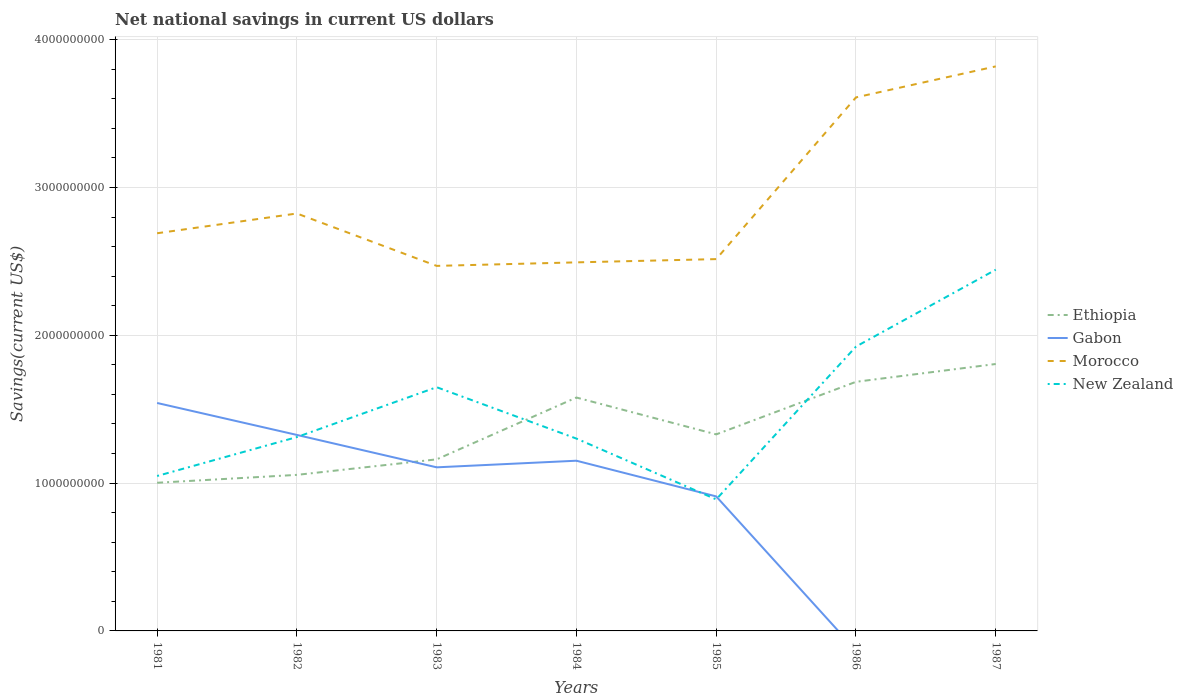How many different coloured lines are there?
Give a very brief answer. 4. Is the number of lines equal to the number of legend labels?
Make the answer very short. No. Across all years, what is the maximum net national savings in New Zealand?
Offer a very short reply. 8.90e+08. What is the total net national savings in Ethiopia in the graph?
Your answer should be very brief. -6.45e+08. What is the difference between the highest and the second highest net national savings in Morocco?
Your answer should be compact. 1.35e+09. How many years are there in the graph?
Give a very brief answer. 7. What is the difference between two consecutive major ticks on the Y-axis?
Keep it short and to the point. 1.00e+09. Are the values on the major ticks of Y-axis written in scientific E-notation?
Offer a very short reply. No. How many legend labels are there?
Keep it short and to the point. 4. What is the title of the graph?
Give a very brief answer. Net national savings in current US dollars. What is the label or title of the Y-axis?
Your response must be concise. Savings(current US$). What is the Savings(current US$) of Ethiopia in 1981?
Keep it short and to the point. 1.00e+09. What is the Savings(current US$) of Gabon in 1981?
Your answer should be compact. 1.54e+09. What is the Savings(current US$) of Morocco in 1981?
Your response must be concise. 2.69e+09. What is the Savings(current US$) in New Zealand in 1981?
Give a very brief answer. 1.05e+09. What is the Savings(current US$) of Ethiopia in 1982?
Your answer should be very brief. 1.06e+09. What is the Savings(current US$) in Gabon in 1982?
Give a very brief answer. 1.33e+09. What is the Savings(current US$) in Morocco in 1982?
Offer a terse response. 2.82e+09. What is the Savings(current US$) in New Zealand in 1982?
Provide a short and direct response. 1.31e+09. What is the Savings(current US$) in Ethiopia in 1983?
Make the answer very short. 1.16e+09. What is the Savings(current US$) of Gabon in 1983?
Your response must be concise. 1.11e+09. What is the Savings(current US$) in Morocco in 1983?
Your answer should be very brief. 2.47e+09. What is the Savings(current US$) of New Zealand in 1983?
Offer a terse response. 1.65e+09. What is the Savings(current US$) in Ethiopia in 1984?
Your answer should be compact. 1.58e+09. What is the Savings(current US$) in Gabon in 1984?
Make the answer very short. 1.15e+09. What is the Savings(current US$) of Morocco in 1984?
Offer a terse response. 2.49e+09. What is the Savings(current US$) of New Zealand in 1984?
Make the answer very short. 1.30e+09. What is the Savings(current US$) in Ethiopia in 1985?
Ensure brevity in your answer.  1.33e+09. What is the Savings(current US$) of Gabon in 1985?
Your answer should be compact. 9.10e+08. What is the Savings(current US$) in Morocco in 1985?
Your answer should be very brief. 2.52e+09. What is the Savings(current US$) in New Zealand in 1985?
Your answer should be very brief. 8.90e+08. What is the Savings(current US$) in Ethiopia in 1986?
Provide a succinct answer. 1.69e+09. What is the Savings(current US$) of Gabon in 1986?
Your response must be concise. 0. What is the Savings(current US$) in Morocco in 1986?
Keep it short and to the point. 3.61e+09. What is the Savings(current US$) in New Zealand in 1986?
Make the answer very short. 1.92e+09. What is the Savings(current US$) of Ethiopia in 1987?
Your answer should be very brief. 1.81e+09. What is the Savings(current US$) of Gabon in 1987?
Provide a succinct answer. 0. What is the Savings(current US$) in Morocco in 1987?
Provide a succinct answer. 3.82e+09. What is the Savings(current US$) in New Zealand in 1987?
Provide a short and direct response. 2.44e+09. Across all years, what is the maximum Savings(current US$) of Ethiopia?
Provide a succinct answer. 1.81e+09. Across all years, what is the maximum Savings(current US$) of Gabon?
Offer a terse response. 1.54e+09. Across all years, what is the maximum Savings(current US$) of Morocco?
Offer a very short reply. 3.82e+09. Across all years, what is the maximum Savings(current US$) in New Zealand?
Provide a succinct answer. 2.44e+09. Across all years, what is the minimum Savings(current US$) of Ethiopia?
Your answer should be compact. 1.00e+09. Across all years, what is the minimum Savings(current US$) of Morocco?
Provide a short and direct response. 2.47e+09. Across all years, what is the minimum Savings(current US$) of New Zealand?
Give a very brief answer. 8.90e+08. What is the total Savings(current US$) in Ethiopia in the graph?
Provide a short and direct response. 9.62e+09. What is the total Savings(current US$) of Gabon in the graph?
Your answer should be very brief. 6.04e+09. What is the total Savings(current US$) of Morocco in the graph?
Make the answer very short. 2.04e+1. What is the total Savings(current US$) of New Zealand in the graph?
Give a very brief answer. 1.06e+1. What is the difference between the Savings(current US$) of Ethiopia in 1981 and that in 1982?
Ensure brevity in your answer.  -5.34e+07. What is the difference between the Savings(current US$) in Gabon in 1981 and that in 1982?
Ensure brevity in your answer.  2.16e+08. What is the difference between the Savings(current US$) of Morocco in 1981 and that in 1982?
Your answer should be compact. -1.34e+08. What is the difference between the Savings(current US$) in New Zealand in 1981 and that in 1982?
Offer a very short reply. -2.63e+08. What is the difference between the Savings(current US$) in Ethiopia in 1981 and that in 1983?
Make the answer very short. -1.58e+08. What is the difference between the Savings(current US$) in Gabon in 1981 and that in 1983?
Make the answer very short. 4.35e+08. What is the difference between the Savings(current US$) in Morocco in 1981 and that in 1983?
Offer a very short reply. 2.21e+08. What is the difference between the Savings(current US$) of New Zealand in 1981 and that in 1983?
Provide a short and direct response. -6.01e+08. What is the difference between the Savings(current US$) of Ethiopia in 1981 and that in 1984?
Give a very brief answer. -5.77e+08. What is the difference between the Savings(current US$) of Gabon in 1981 and that in 1984?
Offer a terse response. 3.91e+08. What is the difference between the Savings(current US$) in Morocco in 1981 and that in 1984?
Ensure brevity in your answer.  1.97e+08. What is the difference between the Savings(current US$) of New Zealand in 1981 and that in 1984?
Keep it short and to the point. -2.53e+08. What is the difference between the Savings(current US$) of Ethiopia in 1981 and that in 1985?
Provide a short and direct response. -3.27e+08. What is the difference between the Savings(current US$) in Gabon in 1981 and that in 1985?
Provide a short and direct response. 6.32e+08. What is the difference between the Savings(current US$) of Morocco in 1981 and that in 1985?
Your response must be concise. 1.75e+08. What is the difference between the Savings(current US$) of New Zealand in 1981 and that in 1985?
Your answer should be compact. 1.58e+08. What is the difference between the Savings(current US$) in Ethiopia in 1981 and that in 1986?
Provide a succinct answer. -6.83e+08. What is the difference between the Savings(current US$) in Morocco in 1981 and that in 1986?
Provide a short and direct response. -9.19e+08. What is the difference between the Savings(current US$) in New Zealand in 1981 and that in 1986?
Offer a terse response. -8.76e+08. What is the difference between the Savings(current US$) in Ethiopia in 1981 and that in 1987?
Offer a very short reply. -8.04e+08. What is the difference between the Savings(current US$) in Morocco in 1981 and that in 1987?
Provide a short and direct response. -1.13e+09. What is the difference between the Savings(current US$) of New Zealand in 1981 and that in 1987?
Give a very brief answer. -1.40e+09. What is the difference between the Savings(current US$) of Ethiopia in 1982 and that in 1983?
Provide a short and direct response. -1.05e+08. What is the difference between the Savings(current US$) of Gabon in 1982 and that in 1983?
Offer a terse response. 2.19e+08. What is the difference between the Savings(current US$) in Morocco in 1982 and that in 1983?
Your answer should be compact. 3.55e+08. What is the difference between the Savings(current US$) in New Zealand in 1982 and that in 1983?
Provide a short and direct response. -3.37e+08. What is the difference between the Savings(current US$) of Ethiopia in 1982 and that in 1984?
Keep it short and to the point. -5.23e+08. What is the difference between the Savings(current US$) in Gabon in 1982 and that in 1984?
Give a very brief answer. 1.74e+08. What is the difference between the Savings(current US$) of Morocco in 1982 and that in 1984?
Your response must be concise. 3.31e+08. What is the difference between the Savings(current US$) in New Zealand in 1982 and that in 1984?
Provide a short and direct response. 1.02e+07. What is the difference between the Savings(current US$) of Ethiopia in 1982 and that in 1985?
Provide a succinct answer. -2.74e+08. What is the difference between the Savings(current US$) in Gabon in 1982 and that in 1985?
Make the answer very short. 4.16e+08. What is the difference between the Savings(current US$) of Morocco in 1982 and that in 1985?
Offer a very short reply. 3.09e+08. What is the difference between the Savings(current US$) in New Zealand in 1982 and that in 1985?
Ensure brevity in your answer.  4.22e+08. What is the difference between the Savings(current US$) of Ethiopia in 1982 and that in 1986?
Provide a succinct answer. -6.30e+08. What is the difference between the Savings(current US$) of Morocco in 1982 and that in 1986?
Ensure brevity in your answer.  -7.86e+08. What is the difference between the Savings(current US$) in New Zealand in 1982 and that in 1986?
Make the answer very short. -6.12e+08. What is the difference between the Savings(current US$) of Ethiopia in 1982 and that in 1987?
Offer a terse response. -7.50e+08. What is the difference between the Savings(current US$) of Morocco in 1982 and that in 1987?
Provide a short and direct response. -9.95e+08. What is the difference between the Savings(current US$) in New Zealand in 1982 and that in 1987?
Offer a very short reply. -1.13e+09. What is the difference between the Savings(current US$) in Ethiopia in 1983 and that in 1984?
Provide a short and direct response. -4.18e+08. What is the difference between the Savings(current US$) in Gabon in 1983 and that in 1984?
Provide a succinct answer. -4.47e+07. What is the difference between the Savings(current US$) in Morocco in 1983 and that in 1984?
Your response must be concise. -2.38e+07. What is the difference between the Savings(current US$) of New Zealand in 1983 and that in 1984?
Provide a succinct answer. 3.48e+08. What is the difference between the Savings(current US$) of Ethiopia in 1983 and that in 1985?
Make the answer very short. -1.69e+08. What is the difference between the Savings(current US$) in Gabon in 1983 and that in 1985?
Provide a succinct answer. 1.97e+08. What is the difference between the Savings(current US$) of Morocco in 1983 and that in 1985?
Make the answer very short. -4.58e+07. What is the difference between the Savings(current US$) in New Zealand in 1983 and that in 1985?
Offer a terse response. 7.59e+08. What is the difference between the Savings(current US$) of Ethiopia in 1983 and that in 1986?
Provide a succinct answer. -5.25e+08. What is the difference between the Savings(current US$) of Morocco in 1983 and that in 1986?
Offer a very short reply. -1.14e+09. What is the difference between the Savings(current US$) in New Zealand in 1983 and that in 1986?
Provide a succinct answer. -2.75e+08. What is the difference between the Savings(current US$) in Ethiopia in 1983 and that in 1987?
Provide a succinct answer. -6.45e+08. What is the difference between the Savings(current US$) of Morocco in 1983 and that in 1987?
Offer a terse response. -1.35e+09. What is the difference between the Savings(current US$) of New Zealand in 1983 and that in 1987?
Provide a short and direct response. -7.95e+08. What is the difference between the Savings(current US$) of Ethiopia in 1984 and that in 1985?
Keep it short and to the point. 2.49e+08. What is the difference between the Savings(current US$) in Gabon in 1984 and that in 1985?
Your answer should be very brief. 2.42e+08. What is the difference between the Savings(current US$) in Morocco in 1984 and that in 1985?
Your answer should be very brief. -2.20e+07. What is the difference between the Savings(current US$) of New Zealand in 1984 and that in 1985?
Provide a short and direct response. 4.11e+08. What is the difference between the Savings(current US$) of Ethiopia in 1984 and that in 1986?
Keep it short and to the point. -1.06e+08. What is the difference between the Savings(current US$) in Morocco in 1984 and that in 1986?
Provide a short and direct response. -1.12e+09. What is the difference between the Savings(current US$) in New Zealand in 1984 and that in 1986?
Your response must be concise. -6.22e+08. What is the difference between the Savings(current US$) of Ethiopia in 1984 and that in 1987?
Ensure brevity in your answer.  -2.27e+08. What is the difference between the Savings(current US$) of Morocco in 1984 and that in 1987?
Your response must be concise. -1.33e+09. What is the difference between the Savings(current US$) of New Zealand in 1984 and that in 1987?
Your answer should be compact. -1.14e+09. What is the difference between the Savings(current US$) in Ethiopia in 1985 and that in 1986?
Provide a short and direct response. -3.56e+08. What is the difference between the Savings(current US$) of Morocco in 1985 and that in 1986?
Offer a terse response. -1.09e+09. What is the difference between the Savings(current US$) of New Zealand in 1985 and that in 1986?
Your answer should be compact. -1.03e+09. What is the difference between the Savings(current US$) in Ethiopia in 1985 and that in 1987?
Provide a succinct answer. -4.76e+08. What is the difference between the Savings(current US$) in Morocco in 1985 and that in 1987?
Ensure brevity in your answer.  -1.30e+09. What is the difference between the Savings(current US$) in New Zealand in 1985 and that in 1987?
Provide a succinct answer. -1.55e+09. What is the difference between the Savings(current US$) of Ethiopia in 1986 and that in 1987?
Ensure brevity in your answer.  -1.20e+08. What is the difference between the Savings(current US$) in Morocco in 1986 and that in 1987?
Your response must be concise. -2.10e+08. What is the difference between the Savings(current US$) in New Zealand in 1986 and that in 1987?
Provide a succinct answer. -5.20e+08. What is the difference between the Savings(current US$) in Ethiopia in 1981 and the Savings(current US$) in Gabon in 1982?
Your answer should be very brief. -3.24e+08. What is the difference between the Savings(current US$) in Ethiopia in 1981 and the Savings(current US$) in Morocco in 1982?
Make the answer very short. -1.82e+09. What is the difference between the Savings(current US$) in Ethiopia in 1981 and the Savings(current US$) in New Zealand in 1982?
Offer a terse response. -3.09e+08. What is the difference between the Savings(current US$) of Gabon in 1981 and the Savings(current US$) of Morocco in 1982?
Provide a succinct answer. -1.28e+09. What is the difference between the Savings(current US$) of Gabon in 1981 and the Savings(current US$) of New Zealand in 1982?
Provide a succinct answer. 2.31e+08. What is the difference between the Savings(current US$) in Morocco in 1981 and the Savings(current US$) in New Zealand in 1982?
Your response must be concise. 1.38e+09. What is the difference between the Savings(current US$) of Ethiopia in 1981 and the Savings(current US$) of Gabon in 1983?
Your response must be concise. -1.05e+08. What is the difference between the Savings(current US$) in Ethiopia in 1981 and the Savings(current US$) in Morocco in 1983?
Make the answer very short. -1.47e+09. What is the difference between the Savings(current US$) in Ethiopia in 1981 and the Savings(current US$) in New Zealand in 1983?
Your answer should be compact. -6.47e+08. What is the difference between the Savings(current US$) of Gabon in 1981 and the Savings(current US$) of Morocco in 1983?
Provide a succinct answer. -9.28e+08. What is the difference between the Savings(current US$) of Gabon in 1981 and the Savings(current US$) of New Zealand in 1983?
Provide a short and direct response. -1.07e+08. What is the difference between the Savings(current US$) in Morocco in 1981 and the Savings(current US$) in New Zealand in 1983?
Make the answer very short. 1.04e+09. What is the difference between the Savings(current US$) of Ethiopia in 1981 and the Savings(current US$) of Gabon in 1984?
Provide a succinct answer. -1.49e+08. What is the difference between the Savings(current US$) in Ethiopia in 1981 and the Savings(current US$) in Morocco in 1984?
Ensure brevity in your answer.  -1.49e+09. What is the difference between the Savings(current US$) in Ethiopia in 1981 and the Savings(current US$) in New Zealand in 1984?
Offer a terse response. -2.99e+08. What is the difference between the Savings(current US$) of Gabon in 1981 and the Savings(current US$) of Morocco in 1984?
Give a very brief answer. -9.51e+08. What is the difference between the Savings(current US$) in Gabon in 1981 and the Savings(current US$) in New Zealand in 1984?
Your response must be concise. 2.41e+08. What is the difference between the Savings(current US$) of Morocco in 1981 and the Savings(current US$) of New Zealand in 1984?
Keep it short and to the point. 1.39e+09. What is the difference between the Savings(current US$) of Ethiopia in 1981 and the Savings(current US$) of Gabon in 1985?
Ensure brevity in your answer.  9.23e+07. What is the difference between the Savings(current US$) in Ethiopia in 1981 and the Savings(current US$) in Morocco in 1985?
Provide a succinct answer. -1.51e+09. What is the difference between the Savings(current US$) of Ethiopia in 1981 and the Savings(current US$) of New Zealand in 1985?
Your answer should be very brief. 1.12e+08. What is the difference between the Savings(current US$) in Gabon in 1981 and the Savings(current US$) in Morocco in 1985?
Offer a very short reply. -9.73e+08. What is the difference between the Savings(current US$) of Gabon in 1981 and the Savings(current US$) of New Zealand in 1985?
Ensure brevity in your answer.  6.52e+08. What is the difference between the Savings(current US$) in Morocco in 1981 and the Savings(current US$) in New Zealand in 1985?
Your answer should be compact. 1.80e+09. What is the difference between the Savings(current US$) of Ethiopia in 1981 and the Savings(current US$) of Morocco in 1986?
Your response must be concise. -2.61e+09. What is the difference between the Savings(current US$) in Ethiopia in 1981 and the Savings(current US$) in New Zealand in 1986?
Your answer should be compact. -9.21e+08. What is the difference between the Savings(current US$) of Gabon in 1981 and the Savings(current US$) of Morocco in 1986?
Keep it short and to the point. -2.07e+09. What is the difference between the Savings(current US$) in Gabon in 1981 and the Savings(current US$) in New Zealand in 1986?
Your response must be concise. -3.81e+08. What is the difference between the Savings(current US$) in Morocco in 1981 and the Savings(current US$) in New Zealand in 1986?
Provide a short and direct response. 7.67e+08. What is the difference between the Savings(current US$) of Ethiopia in 1981 and the Savings(current US$) of Morocco in 1987?
Offer a terse response. -2.82e+09. What is the difference between the Savings(current US$) of Ethiopia in 1981 and the Savings(current US$) of New Zealand in 1987?
Give a very brief answer. -1.44e+09. What is the difference between the Savings(current US$) of Gabon in 1981 and the Savings(current US$) of Morocco in 1987?
Offer a very short reply. -2.28e+09. What is the difference between the Savings(current US$) in Gabon in 1981 and the Savings(current US$) in New Zealand in 1987?
Provide a succinct answer. -9.02e+08. What is the difference between the Savings(current US$) of Morocco in 1981 and the Savings(current US$) of New Zealand in 1987?
Keep it short and to the point. 2.47e+08. What is the difference between the Savings(current US$) of Ethiopia in 1982 and the Savings(current US$) of Gabon in 1983?
Provide a succinct answer. -5.11e+07. What is the difference between the Savings(current US$) in Ethiopia in 1982 and the Savings(current US$) in Morocco in 1983?
Ensure brevity in your answer.  -1.41e+09. What is the difference between the Savings(current US$) in Ethiopia in 1982 and the Savings(current US$) in New Zealand in 1983?
Give a very brief answer. -5.93e+08. What is the difference between the Savings(current US$) in Gabon in 1982 and the Savings(current US$) in Morocco in 1983?
Give a very brief answer. -1.14e+09. What is the difference between the Savings(current US$) in Gabon in 1982 and the Savings(current US$) in New Zealand in 1983?
Your answer should be compact. -3.23e+08. What is the difference between the Savings(current US$) in Morocco in 1982 and the Savings(current US$) in New Zealand in 1983?
Provide a short and direct response. 1.18e+09. What is the difference between the Savings(current US$) in Ethiopia in 1982 and the Savings(current US$) in Gabon in 1984?
Offer a terse response. -9.58e+07. What is the difference between the Savings(current US$) of Ethiopia in 1982 and the Savings(current US$) of Morocco in 1984?
Keep it short and to the point. -1.44e+09. What is the difference between the Savings(current US$) of Ethiopia in 1982 and the Savings(current US$) of New Zealand in 1984?
Give a very brief answer. -2.46e+08. What is the difference between the Savings(current US$) of Gabon in 1982 and the Savings(current US$) of Morocco in 1984?
Keep it short and to the point. -1.17e+09. What is the difference between the Savings(current US$) in Gabon in 1982 and the Savings(current US$) in New Zealand in 1984?
Ensure brevity in your answer.  2.48e+07. What is the difference between the Savings(current US$) of Morocco in 1982 and the Savings(current US$) of New Zealand in 1984?
Ensure brevity in your answer.  1.52e+09. What is the difference between the Savings(current US$) of Ethiopia in 1982 and the Savings(current US$) of Gabon in 1985?
Offer a terse response. 1.46e+08. What is the difference between the Savings(current US$) in Ethiopia in 1982 and the Savings(current US$) in Morocco in 1985?
Your response must be concise. -1.46e+09. What is the difference between the Savings(current US$) of Ethiopia in 1982 and the Savings(current US$) of New Zealand in 1985?
Your response must be concise. 1.66e+08. What is the difference between the Savings(current US$) in Gabon in 1982 and the Savings(current US$) in Morocco in 1985?
Offer a terse response. -1.19e+09. What is the difference between the Savings(current US$) of Gabon in 1982 and the Savings(current US$) of New Zealand in 1985?
Provide a succinct answer. 4.36e+08. What is the difference between the Savings(current US$) of Morocco in 1982 and the Savings(current US$) of New Zealand in 1985?
Your response must be concise. 1.93e+09. What is the difference between the Savings(current US$) of Ethiopia in 1982 and the Savings(current US$) of Morocco in 1986?
Provide a short and direct response. -2.55e+09. What is the difference between the Savings(current US$) in Ethiopia in 1982 and the Savings(current US$) in New Zealand in 1986?
Offer a very short reply. -8.68e+08. What is the difference between the Savings(current US$) in Gabon in 1982 and the Savings(current US$) in Morocco in 1986?
Your response must be concise. -2.28e+09. What is the difference between the Savings(current US$) of Gabon in 1982 and the Savings(current US$) of New Zealand in 1986?
Your response must be concise. -5.98e+08. What is the difference between the Savings(current US$) of Morocco in 1982 and the Savings(current US$) of New Zealand in 1986?
Your response must be concise. 9.01e+08. What is the difference between the Savings(current US$) in Ethiopia in 1982 and the Savings(current US$) in Morocco in 1987?
Make the answer very short. -2.76e+09. What is the difference between the Savings(current US$) of Ethiopia in 1982 and the Savings(current US$) of New Zealand in 1987?
Provide a succinct answer. -1.39e+09. What is the difference between the Savings(current US$) of Gabon in 1982 and the Savings(current US$) of Morocco in 1987?
Provide a short and direct response. -2.49e+09. What is the difference between the Savings(current US$) in Gabon in 1982 and the Savings(current US$) in New Zealand in 1987?
Your answer should be very brief. -1.12e+09. What is the difference between the Savings(current US$) of Morocco in 1982 and the Savings(current US$) of New Zealand in 1987?
Offer a terse response. 3.80e+08. What is the difference between the Savings(current US$) of Ethiopia in 1983 and the Savings(current US$) of Gabon in 1984?
Provide a short and direct response. 9.15e+06. What is the difference between the Savings(current US$) in Ethiopia in 1983 and the Savings(current US$) in Morocco in 1984?
Give a very brief answer. -1.33e+09. What is the difference between the Savings(current US$) of Ethiopia in 1983 and the Savings(current US$) of New Zealand in 1984?
Your answer should be very brief. -1.41e+08. What is the difference between the Savings(current US$) in Gabon in 1983 and the Savings(current US$) in Morocco in 1984?
Provide a succinct answer. -1.39e+09. What is the difference between the Savings(current US$) in Gabon in 1983 and the Savings(current US$) in New Zealand in 1984?
Provide a short and direct response. -1.94e+08. What is the difference between the Savings(current US$) of Morocco in 1983 and the Savings(current US$) of New Zealand in 1984?
Provide a succinct answer. 1.17e+09. What is the difference between the Savings(current US$) in Ethiopia in 1983 and the Savings(current US$) in Gabon in 1985?
Your response must be concise. 2.51e+08. What is the difference between the Savings(current US$) of Ethiopia in 1983 and the Savings(current US$) of Morocco in 1985?
Keep it short and to the point. -1.35e+09. What is the difference between the Savings(current US$) of Ethiopia in 1983 and the Savings(current US$) of New Zealand in 1985?
Your answer should be compact. 2.71e+08. What is the difference between the Savings(current US$) of Gabon in 1983 and the Savings(current US$) of Morocco in 1985?
Keep it short and to the point. -1.41e+09. What is the difference between the Savings(current US$) in Gabon in 1983 and the Savings(current US$) in New Zealand in 1985?
Give a very brief answer. 2.17e+08. What is the difference between the Savings(current US$) in Morocco in 1983 and the Savings(current US$) in New Zealand in 1985?
Your answer should be compact. 1.58e+09. What is the difference between the Savings(current US$) of Ethiopia in 1983 and the Savings(current US$) of Morocco in 1986?
Your answer should be very brief. -2.45e+09. What is the difference between the Savings(current US$) in Ethiopia in 1983 and the Savings(current US$) in New Zealand in 1986?
Provide a succinct answer. -7.63e+08. What is the difference between the Savings(current US$) in Gabon in 1983 and the Savings(current US$) in Morocco in 1986?
Provide a short and direct response. -2.50e+09. What is the difference between the Savings(current US$) of Gabon in 1983 and the Savings(current US$) of New Zealand in 1986?
Provide a short and direct response. -8.17e+08. What is the difference between the Savings(current US$) of Morocco in 1983 and the Savings(current US$) of New Zealand in 1986?
Your response must be concise. 5.46e+08. What is the difference between the Savings(current US$) in Ethiopia in 1983 and the Savings(current US$) in Morocco in 1987?
Provide a succinct answer. -2.66e+09. What is the difference between the Savings(current US$) of Ethiopia in 1983 and the Savings(current US$) of New Zealand in 1987?
Give a very brief answer. -1.28e+09. What is the difference between the Savings(current US$) of Gabon in 1983 and the Savings(current US$) of Morocco in 1987?
Give a very brief answer. -2.71e+09. What is the difference between the Savings(current US$) in Gabon in 1983 and the Savings(current US$) in New Zealand in 1987?
Your response must be concise. -1.34e+09. What is the difference between the Savings(current US$) in Morocco in 1983 and the Savings(current US$) in New Zealand in 1987?
Make the answer very short. 2.60e+07. What is the difference between the Savings(current US$) of Ethiopia in 1984 and the Savings(current US$) of Gabon in 1985?
Ensure brevity in your answer.  6.69e+08. What is the difference between the Savings(current US$) in Ethiopia in 1984 and the Savings(current US$) in Morocco in 1985?
Give a very brief answer. -9.37e+08. What is the difference between the Savings(current US$) of Ethiopia in 1984 and the Savings(current US$) of New Zealand in 1985?
Keep it short and to the point. 6.89e+08. What is the difference between the Savings(current US$) of Gabon in 1984 and the Savings(current US$) of Morocco in 1985?
Your answer should be very brief. -1.36e+09. What is the difference between the Savings(current US$) of Gabon in 1984 and the Savings(current US$) of New Zealand in 1985?
Offer a very short reply. 2.62e+08. What is the difference between the Savings(current US$) in Morocco in 1984 and the Savings(current US$) in New Zealand in 1985?
Ensure brevity in your answer.  1.60e+09. What is the difference between the Savings(current US$) of Ethiopia in 1984 and the Savings(current US$) of Morocco in 1986?
Your answer should be compact. -2.03e+09. What is the difference between the Savings(current US$) of Ethiopia in 1984 and the Savings(current US$) of New Zealand in 1986?
Ensure brevity in your answer.  -3.45e+08. What is the difference between the Savings(current US$) in Gabon in 1984 and the Savings(current US$) in Morocco in 1986?
Ensure brevity in your answer.  -2.46e+09. What is the difference between the Savings(current US$) in Gabon in 1984 and the Savings(current US$) in New Zealand in 1986?
Provide a succinct answer. -7.72e+08. What is the difference between the Savings(current US$) of Morocco in 1984 and the Savings(current US$) of New Zealand in 1986?
Offer a terse response. 5.70e+08. What is the difference between the Savings(current US$) of Ethiopia in 1984 and the Savings(current US$) of Morocco in 1987?
Provide a succinct answer. -2.24e+09. What is the difference between the Savings(current US$) of Ethiopia in 1984 and the Savings(current US$) of New Zealand in 1987?
Your response must be concise. -8.65e+08. What is the difference between the Savings(current US$) of Gabon in 1984 and the Savings(current US$) of Morocco in 1987?
Provide a short and direct response. -2.67e+09. What is the difference between the Savings(current US$) in Gabon in 1984 and the Savings(current US$) in New Zealand in 1987?
Your answer should be compact. -1.29e+09. What is the difference between the Savings(current US$) in Morocco in 1984 and the Savings(current US$) in New Zealand in 1987?
Your answer should be very brief. 4.98e+07. What is the difference between the Savings(current US$) of Ethiopia in 1985 and the Savings(current US$) of Morocco in 1986?
Provide a short and direct response. -2.28e+09. What is the difference between the Savings(current US$) of Ethiopia in 1985 and the Savings(current US$) of New Zealand in 1986?
Keep it short and to the point. -5.94e+08. What is the difference between the Savings(current US$) in Gabon in 1985 and the Savings(current US$) in Morocco in 1986?
Offer a very short reply. -2.70e+09. What is the difference between the Savings(current US$) in Gabon in 1985 and the Savings(current US$) in New Zealand in 1986?
Provide a short and direct response. -1.01e+09. What is the difference between the Savings(current US$) of Morocco in 1985 and the Savings(current US$) of New Zealand in 1986?
Give a very brief answer. 5.92e+08. What is the difference between the Savings(current US$) of Ethiopia in 1985 and the Savings(current US$) of Morocco in 1987?
Keep it short and to the point. -2.49e+09. What is the difference between the Savings(current US$) in Ethiopia in 1985 and the Savings(current US$) in New Zealand in 1987?
Ensure brevity in your answer.  -1.11e+09. What is the difference between the Savings(current US$) in Gabon in 1985 and the Savings(current US$) in Morocco in 1987?
Provide a succinct answer. -2.91e+09. What is the difference between the Savings(current US$) in Gabon in 1985 and the Savings(current US$) in New Zealand in 1987?
Ensure brevity in your answer.  -1.53e+09. What is the difference between the Savings(current US$) of Morocco in 1985 and the Savings(current US$) of New Zealand in 1987?
Ensure brevity in your answer.  7.18e+07. What is the difference between the Savings(current US$) in Ethiopia in 1986 and the Savings(current US$) in Morocco in 1987?
Provide a succinct answer. -2.13e+09. What is the difference between the Savings(current US$) in Ethiopia in 1986 and the Savings(current US$) in New Zealand in 1987?
Offer a very short reply. -7.58e+08. What is the difference between the Savings(current US$) of Morocco in 1986 and the Savings(current US$) of New Zealand in 1987?
Your answer should be compact. 1.17e+09. What is the average Savings(current US$) of Ethiopia per year?
Provide a succinct answer. 1.37e+09. What is the average Savings(current US$) in Gabon per year?
Ensure brevity in your answer.  8.62e+08. What is the average Savings(current US$) of Morocco per year?
Your answer should be very brief. 2.92e+09. What is the average Savings(current US$) of New Zealand per year?
Make the answer very short. 1.51e+09. In the year 1981, what is the difference between the Savings(current US$) of Ethiopia and Savings(current US$) of Gabon?
Offer a terse response. -5.40e+08. In the year 1981, what is the difference between the Savings(current US$) of Ethiopia and Savings(current US$) of Morocco?
Provide a succinct answer. -1.69e+09. In the year 1981, what is the difference between the Savings(current US$) of Ethiopia and Savings(current US$) of New Zealand?
Provide a short and direct response. -4.58e+07. In the year 1981, what is the difference between the Savings(current US$) in Gabon and Savings(current US$) in Morocco?
Your answer should be very brief. -1.15e+09. In the year 1981, what is the difference between the Savings(current US$) in Gabon and Savings(current US$) in New Zealand?
Give a very brief answer. 4.94e+08. In the year 1981, what is the difference between the Savings(current US$) in Morocco and Savings(current US$) in New Zealand?
Offer a terse response. 1.64e+09. In the year 1982, what is the difference between the Savings(current US$) of Ethiopia and Savings(current US$) of Gabon?
Provide a short and direct response. -2.70e+08. In the year 1982, what is the difference between the Savings(current US$) in Ethiopia and Savings(current US$) in Morocco?
Your response must be concise. -1.77e+09. In the year 1982, what is the difference between the Savings(current US$) in Ethiopia and Savings(current US$) in New Zealand?
Provide a short and direct response. -2.56e+08. In the year 1982, what is the difference between the Savings(current US$) of Gabon and Savings(current US$) of Morocco?
Keep it short and to the point. -1.50e+09. In the year 1982, what is the difference between the Savings(current US$) in Gabon and Savings(current US$) in New Zealand?
Your answer should be compact. 1.45e+07. In the year 1982, what is the difference between the Savings(current US$) of Morocco and Savings(current US$) of New Zealand?
Provide a succinct answer. 1.51e+09. In the year 1983, what is the difference between the Savings(current US$) of Ethiopia and Savings(current US$) of Gabon?
Ensure brevity in your answer.  5.39e+07. In the year 1983, what is the difference between the Savings(current US$) of Ethiopia and Savings(current US$) of Morocco?
Your response must be concise. -1.31e+09. In the year 1983, what is the difference between the Savings(current US$) in Ethiopia and Savings(current US$) in New Zealand?
Ensure brevity in your answer.  -4.88e+08. In the year 1983, what is the difference between the Savings(current US$) of Gabon and Savings(current US$) of Morocco?
Provide a succinct answer. -1.36e+09. In the year 1983, what is the difference between the Savings(current US$) of Gabon and Savings(current US$) of New Zealand?
Your response must be concise. -5.42e+08. In the year 1983, what is the difference between the Savings(current US$) of Morocco and Savings(current US$) of New Zealand?
Ensure brevity in your answer.  8.21e+08. In the year 1984, what is the difference between the Savings(current US$) of Ethiopia and Savings(current US$) of Gabon?
Provide a short and direct response. 4.27e+08. In the year 1984, what is the difference between the Savings(current US$) in Ethiopia and Savings(current US$) in Morocco?
Your answer should be very brief. -9.14e+08. In the year 1984, what is the difference between the Savings(current US$) in Ethiopia and Savings(current US$) in New Zealand?
Provide a succinct answer. 2.78e+08. In the year 1984, what is the difference between the Savings(current US$) in Gabon and Savings(current US$) in Morocco?
Provide a succinct answer. -1.34e+09. In the year 1984, what is the difference between the Savings(current US$) in Gabon and Savings(current US$) in New Zealand?
Make the answer very short. -1.50e+08. In the year 1984, what is the difference between the Savings(current US$) in Morocco and Savings(current US$) in New Zealand?
Offer a terse response. 1.19e+09. In the year 1985, what is the difference between the Savings(current US$) of Ethiopia and Savings(current US$) of Gabon?
Keep it short and to the point. 4.20e+08. In the year 1985, what is the difference between the Savings(current US$) in Ethiopia and Savings(current US$) in Morocco?
Keep it short and to the point. -1.19e+09. In the year 1985, what is the difference between the Savings(current US$) of Ethiopia and Savings(current US$) of New Zealand?
Provide a short and direct response. 4.40e+08. In the year 1985, what is the difference between the Savings(current US$) of Gabon and Savings(current US$) of Morocco?
Offer a very short reply. -1.61e+09. In the year 1985, what is the difference between the Savings(current US$) in Gabon and Savings(current US$) in New Zealand?
Your answer should be compact. 2.02e+07. In the year 1985, what is the difference between the Savings(current US$) in Morocco and Savings(current US$) in New Zealand?
Your response must be concise. 1.63e+09. In the year 1986, what is the difference between the Savings(current US$) in Ethiopia and Savings(current US$) in Morocco?
Your answer should be compact. -1.92e+09. In the year 1986, what is the difference between the Savings(current US$) of Ethiopia and Savings(current US$) of New Zealand?
Your answer should be compact. -2.38e+08. In the year 1986, what is the difference between the Savings(current US$) of Morocco and Savings(current US$) of New Zealand?
Your answer should be compact. 1.69e+09. In the year 1987, what is the difference between the Savings(current US$) of Ethiopia and Savings(current US$) of Morocco?
Offer a very short reply. -2.01e+09. In the year 1987, what is the difference between the Savings(current US$) in Ethiopia and Savings(current US$) in New Zealand?
Your answer should be compact. -6.38e+08. In the year 1987, what is the difference between the Savings(current US$) of Morocco and Savings(current US$) of New Zealand?
Offer a terse response. 1.38e+09. What is the ratio of the Savings(current US$) of Ethiopia in 1981 to that in 1982?
Your answer should be compact. 0.95. What is the ratio of the Savings(current US$) in Gabon in 1981 to that in 1982?
Your response must be concise. 1.16. What is the ratio of the Savings(current US$) of Morocco in 1981 to that in 1982?
Keep it short and to the point. 0.95. What is the ratio of the Savings(current US$) in New Zealand in 1981 to that in 1982?
Your answer should be very brief. 0.8. What is the ratio of the Savings(current US$) in Ethiopia in 1981 to that in 1983?
Give a very brief answer. 0.86. What is the ratio of the Savings(current US$) of Gabon in 1981 to that in 1983?
Keep it short and to the point. 1.39. What is the ratio of the Savings(current US$) in Morocco in 1981 to that in 1983?
Ensure brevity in your answer.  1.09. What is the ratio of the Savings(current US$) in New Zealand in 1981 to that in 1983?
Give a very brief answer. 0.64. What is the ratio of the Savings(current US$) in Ethiopia in 1981 to that in 1984?
Your response must be concise. 0.63. What is the ratio of the Savings(current US$) of Gabon in 1981 to that in 1984?
Your answer should be very brief. 1.34. What is the ratio of the Savings(current US$) in Morocco in 1981 to that in 1984?
Ensure brevity in your answer.  1.08. What is the ratio of the Savings(current US$) in New Zealand in 1981 to that in 1984?
Keep it short and to the point. 0.81. What is the ratio of the Savings(current US$) of Ethiopia in 1981 to that in 1985?
Keep it short and to the point. 0.75. What is the ratio of the Savings(current US$) in Gabon in 1981 to that in 1985?
Your answer should be very brief. 1.69. What is the ratio of the Savings(current US$) of Morocco in 1981 to that in 1985?
Provide a succinct answer. 1.07. What is the ratio of the Savings(current US$) of New Zealand in 1981 to that in 1985?
Provide a short and direct response. 1.18. What is the ratio of the Savings(current US$) of Ethiopia in 1981 to that in 1986?
Provide a succinct answer. 0.59. What is the ratio of the Savings(current US$) in Morocco in 1981 to that in 1986?
Your answer should be compact. 0.75. What is the ratio of the Savings(current US$) in New Zealand in 1981 to that in 1986?
Keep it short and to the point. 0.54. What is the ratio of the Savings(current US$) in Ethiopia in 1981 to that in 1987?
Ensure brevity in your answer.  0.56. What is the ratio of the Savings(current US$) of Morocco in 1981 to that in 1987?
Offer a terse response. 0.7. What is the ratio of the Savings(current US$) of New Zealand in 1981 to that in 1987?
Give a very brief answer. 0.43. What is the ratio of the Savings(current US$) of Ethiopia in 1982 to that in 1983?
Your answer should be compact. 0.91. What is the ratio of the Savings(current US$) in Gabon in 1982 to that in 1983?
Offer a very short reply. 1.2. What is the ratio of the Savings(current US$) in Morocco in 1982 to that in 1983?
Your answer should be very brief. 1.14. What is the ratio of the Savings(current US$) of New Zealand in 1982 to that in 1983?
Your answer should be compact. 0.8. What is the ratio of the Savings(current US$) in Ethiopia in 1982 to that in 1984?
Provide a succinct answer. 0.67. What is the ratio of the Savings(current US$) of Gabon in 1982 to that in 1984?
Your answer should be very brief. 1.15. What is the ratio of the Savings(current US$) of Morocco in 1982 to that in 1984?
Keep it short and to the point. 1.13. What is the ratio of the Savings(current US$) of New Zealand in 1982 to that in 1984?
Your response must be concise. 1.01. What is the ratio of the Savings(current US$) of Ethiopia in 1982 to that in 1985?
Give a very brief answer. 0.79. What is the ratio of the Savings(current US$) in Gabon in 1982 to that in 1985?
Provide a succinct answer. 1.46. What is the ratio of the Savings(current US$) in Morocco in 1982 to that in 1985?
Offer a terse response. 1.12. What is the ratio of the Savings(current US$) of New Zealand in 1982 to that in 1985?
Your response must be concise. 1.47. What is the ratio of the Savings(current US$) in Ethiopia in 1982 to that in 1986?
Your answer should be very brief. 0.63. What is the ratio of the Savings(current US$) of Morocco in 1982 to that in 1986?
Provide a short and direct response. 0.78. What is the ratio of the Savings(current US$) of New Zealand in 1982 to that in 1986?
Offer a very short reply. 0.68. What is the ratio of the Savings(current US$) of Ethiopia in 1982 to that in 1987?
Make the answer very short. 0.58. What is the ratio of the Savings(current US$) of Morocco in 1982 to that in 1987?
Make the answer very short. 0.74. What is the ratio of the Savings(current US$) in New Zealand in 1982 to that in 1987?
Offer a very short reply. 0.54. What is the ratio of the Savings(current US$) of Ethiopia in 1983 to that in 1984?
Offer a very short reply. 0.74. What is the ratio of the Savings(current US$) in Gabon in 1983 to that in 1984?
Your answer should be very brief. 0.96. What is the ratio of the Savings(current US$) of New Zealand in 1983 to that in 1984?
Provide a succinct answer. 1.27. What is the ratio of the Savings(current US$) in Ethiopia in 1983 to that in 1985?
Give a very brief answer. 0.87. What is the ratio of the Savings(current US$) in Gabon in 1983 to that in 1985?
Offer a very short reply. 1.22. What is the ratio of the Savings(current US$) of Morocco in 1983 to that in 1985?
Give a very brief answer. 0.98. What is the ratio of the Savings(current US$) of New Zealand in 1983 to that in 1985?
Your answer should be compact. 1.85. What is the ratio of the Savings(current US$) of Ethiopia in 1983 to that in 1986?
Your response must be concise. 0.69. What is the ratio of the Savings(current US$) of Morocco in 1983 to that in 1986?
Ensure brevity in your answer.  0.68. What is the ratio of the Savings(current US$) of New Zealand in 1983 to that in 1986?
Your answer should be compact. 0.86. What is the ratio of the Savings(current US$) in Ethiopia in 1983 to that in 1987?
Offer a terse response. 0.64. What is the ratio of the Savings(current US$) of Morocco in 1983 to that in 1987?
Provide a succinct answer. 0.65. What is the ratio of the Savings(current US$) of New Zealand in 1983 to that in 1987?
Offer a very short reply. 0.67. What is the ratio of the Savings(current US$) of Ethiopia in 1984 to that in 1985?
Your answer should be very brief. 1.19. What is the ratio of the Savings(current US$) of Gabon in 1984 to that in 1985?
Provide a succinct answer. 1.27. What is the ratio of the Savings(current US$) in Morocco in 1984 to that in 1985?
Provide a succinct answer. 0.99. What is the ratio of the Savings(current US$) of New Zealand in 1984 to that in 1985?
Ensure brevity in your answer.  1.46. What is the ratio of the Savings(current US$) in Ethiopia in 1984 to that in 1986?
Offer a terse response. 0.94. What is the ratio of the Savings(current US$) of Morocco in 1984 to that in 1986?
Your response must be concise. 0.69. What is the ratio of the Savings(current US$) of New Zealand in 1984 to that in 1986?
Ensure brevity in your answer.  0.68. What is the ratio of the Savings(current US$) in Ethiopia in 1984 to that in 1987?
Your answer should be compact. 0.87. What is the ratio of the Savings(current US$) in Morocco in 1984 to that in 1987?
Your answer should be compact. 0.65. What is the ratio of the Savings(current US$) of New Zealand in 1984 to that in 1987?
Offer a very short reply. 0.53. What is the ratio of the Savings(current US$) in Ethiopia in 1985 to that in 1986?
Keep it short and to the point. 0.79. What is the ratio of the Savings(current US$) of Morocco in 1985 to that in 1986?
Offer a terse response. 0.7. What is the ratio of the Savings(current US$) in New Zealand in 1985 to that in 1986?
Ensure brevity in your answer.  0.46. What is the ratio of the Savings(current US$) in Ethiopia in 1985 to that in 1987?
Your answer should be compact. 0.74. What is the ratio of the Savings(current US$) in Morocco in 1985 to that in 1987?
Give a very brief answer. 0.66. What is the ratio of the Savings(current US$) of New Zealand in 1985 to that in 1987?
Make the answer very short. 0.36. What is the ratio of the Savings(current US$) in Ethiopia in 1986 to that in 1987?
Your answer should be compact. 0.93. What is the ratio of the Savings(current US$) in Morocco in 1986 to that in 1987?
Offer a terse response. 0.95. What is the ratio of the Savings(current US$) of New Zealand in 1986 to that in 1987?
Offer a very short reply. 0.79. What is the difference between the highest and the second highest Savings(current US$) in Ethiopia?
Give a very brief answer. 1.20e+08. What is the difference between the highest and the second highest Savings(current US$) of Gabon?
Your response must be concise. 2.16e+08. What is the difference between the highest and the second highest Savings(current US$) of Morocco?
Offer a very short reply. 2.10e+08. What is the difference between the highest and the second highest Savings(current US$) of New Zealand?
Your response must be concise. 5.20e+08. What is the difference between the highest and the lowest Savings(current US$) in Ethiopia?
Your answer should be compact. 8.04e+08. What is the difference between the highest and the lowest Savings(current US$) in Gabon?
Offer a terse response. 1.54e+09. What is the difference between the highest and the lowest Savings(current US$) in Morocco?
Give a very brief answer. 1.35e+09. What is the difference between the highest and the lowest Savings(current US$) of New Zealand?
Your answer should be very brief. 1.55e+09. 